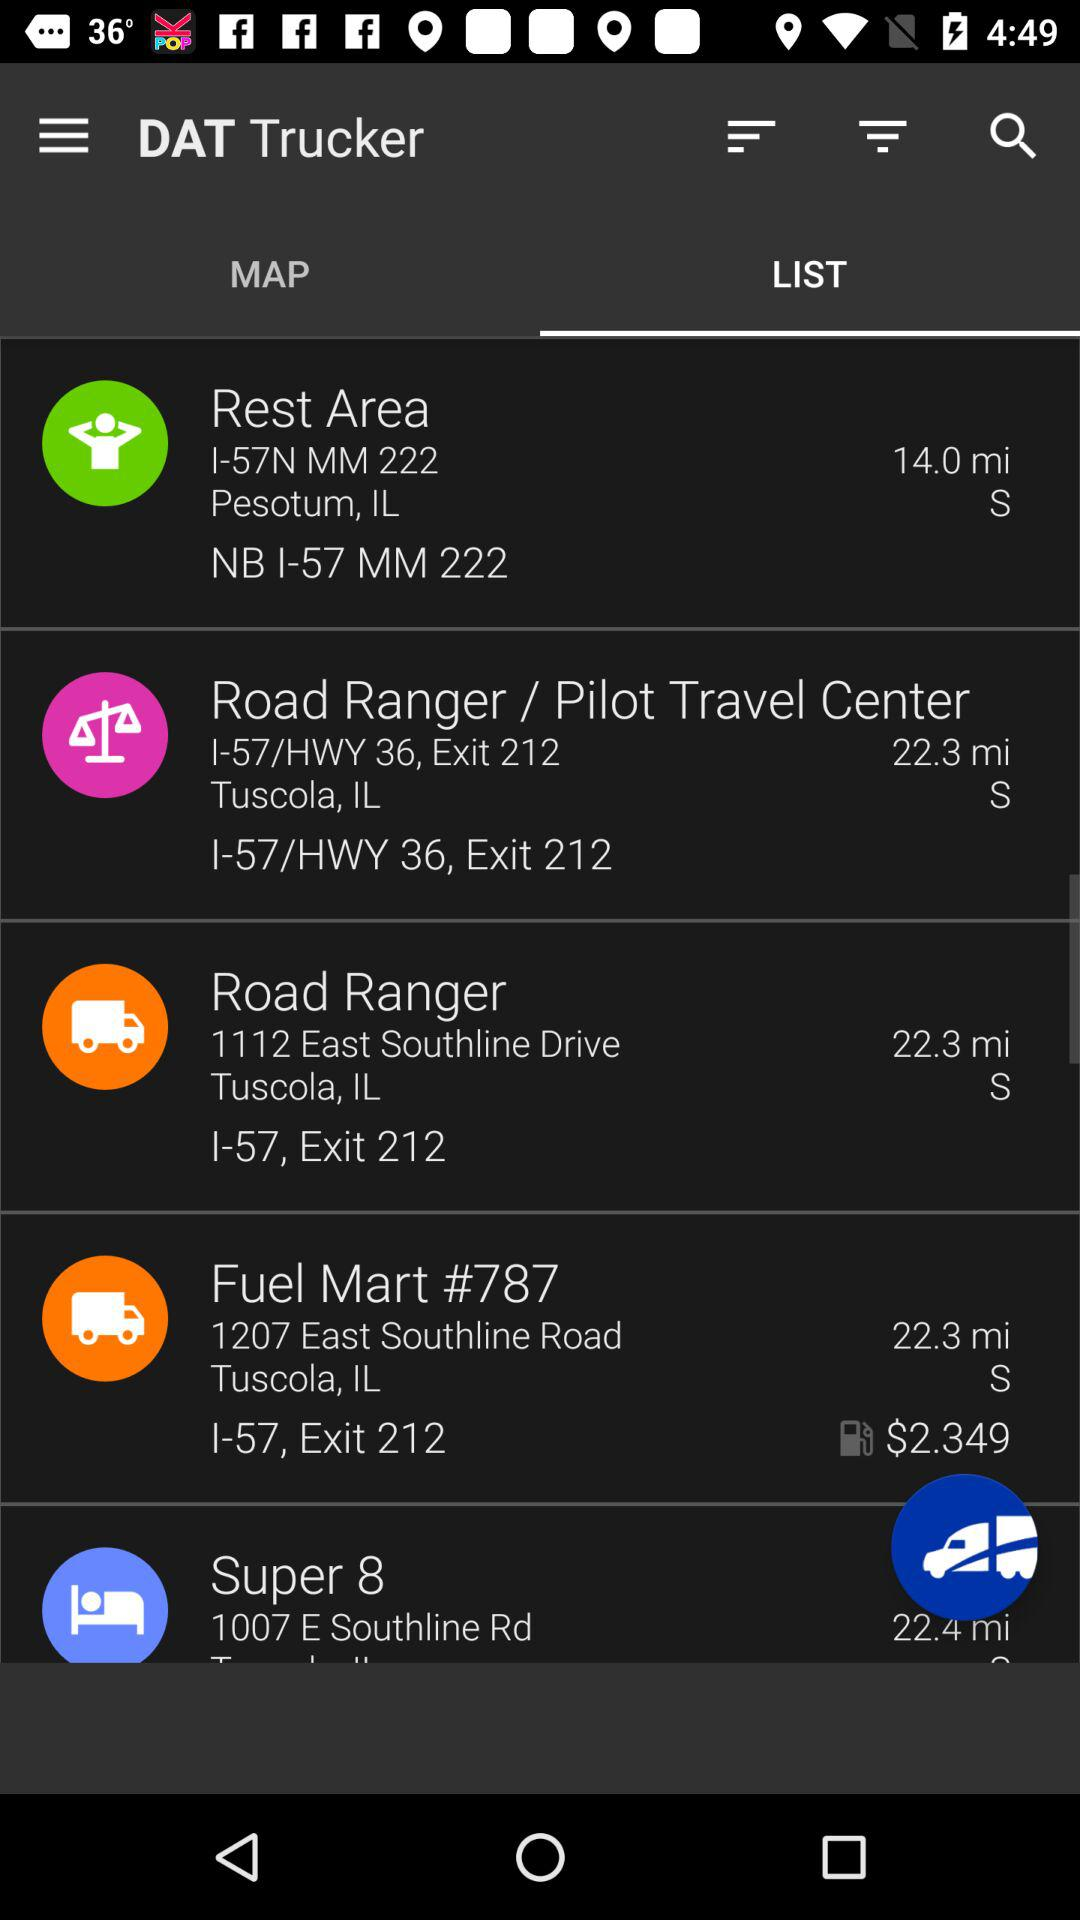What is the location of the "Rest Area"? The location of the "Rest Area" is "1-57N MM 222, Pesotum, IL, NB I-57 MM 222". 